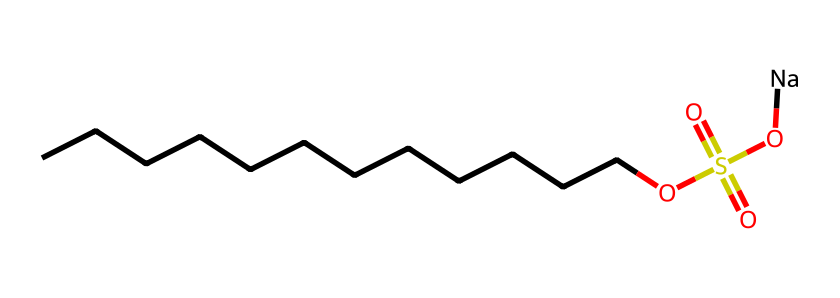How many carbon atoms are in the molecule? The SMILES representation shows a long chain of carbon atoms represented by the 'C' characters. Counting the 'C's gives us twelve carbon atoms.
Answer: twelve What functional group is present in this molecule? Looking at the structure, the presence of the 'OS(=O)(=O)O' portion indicates the presence of a sulfonate group. This functional group is characteristic of detergents.
Answer: sulfonate How many oxygen atoms are found in the molecule? The SMILES also includes four 'O' symbols, which represent the oxygen atoms in the structure. Counting these leads us to find there are four oxygen atoms total.
Answer: four Which part of this molecule is responsible for its detergent properties? The sulfonate group 'OS(=O)(=O)O' gives the molecule its detergent properties due to its ability to interact with both water and oils, allowing it to emulsify and clean.
Answer: sulfonate group What type of ions are present due to the 'Na' at the end? The 'Na' at the end indicates the presence of sodium ions, which are common in detergent formulations to create a stable solution.
Answer: sodium ions Is this molecule hydrophobic or hydrophilic? The presence of a long hydrocarbon chain (the 'CCCCCCCCCCCC') makes it hydrophobic, while the sulfonate part contributes to its hydrophilic properties. However, overall, its mixed nature makes it amphiphilic.
Answer: amphiphilic 